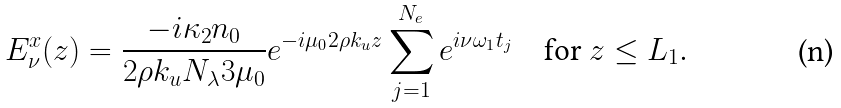<formula> <loc_0><loc_0><loc_500><loc_500>E _ { \nu } ^ { x } ( z ) & = \frac { - i \kappa _ { 2 } n _ { 0 } } { 2 \rho k _ { u } N _ { \lambda } 3 \mu _ { 0 } } e ^ { - i \mu _ { 0 } 2 \rho k _ { u } z } \sum ^ { N _ { e } } _ { j = 1 } e ^ { i \nu \omega _ { 1 } t _ { j } } \quad \text {for $z\leq L_{1}$.}</formula> 